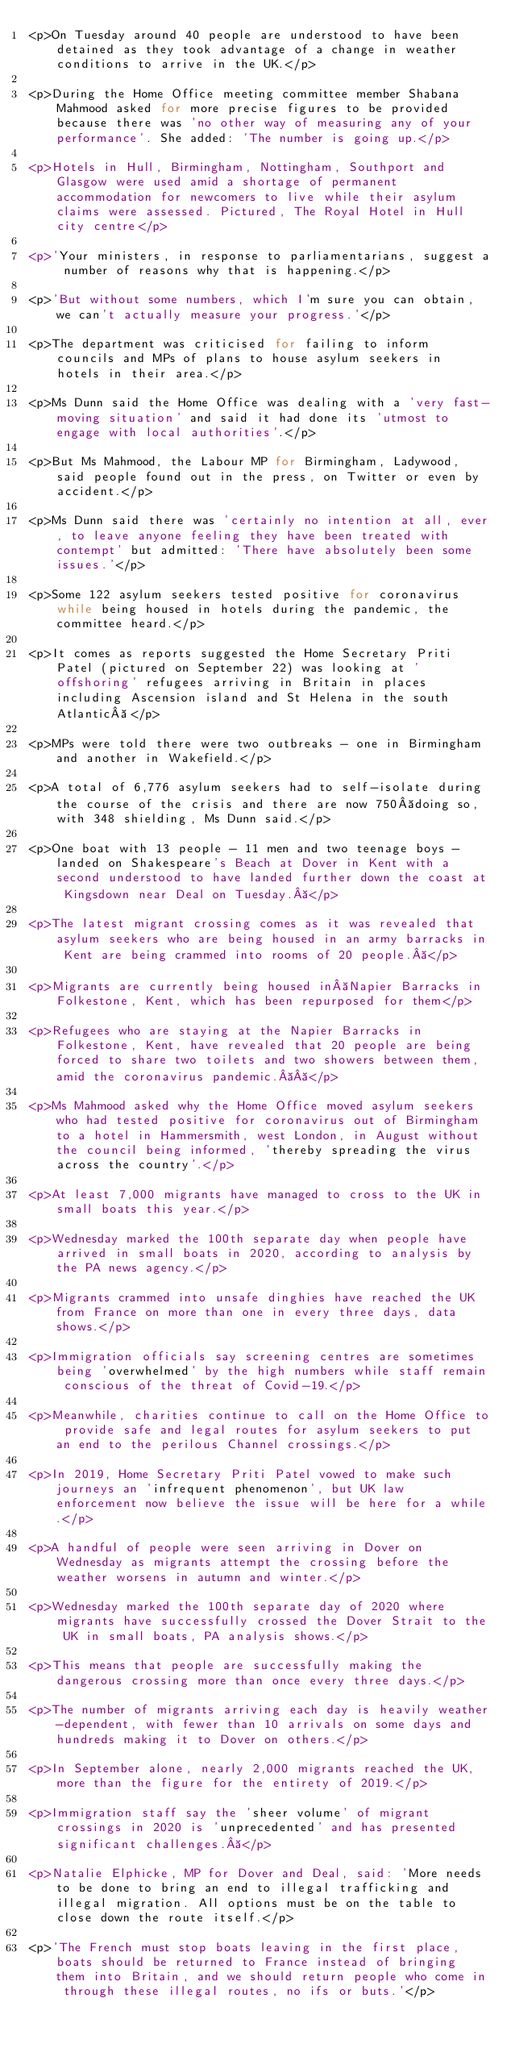Convert code to text. <code><loc_0><loc_0><loc_500><loc_500><_PHP_><p>On Tuesday around 40 people are understood to have been detained as they took advantage of a change in weather conditions to arrive in the UK.</p>

<p>During the Home Office meeting committee member Shabana Mahmood asked for more precise figures to be provided because there was 'no other way of measuring any of your performance'. She added: 'The number is going up.</p>

<p>Hotels in Hull, Birmingham, Nottingham, Southport and Glasgow were used amid a shortage of permanent accommodation for newcomers to live while their asylum claims were assessed. Pictured, The Royal Hotel in Hull city centre</p>

<p>'Your ministers, in response to parliamentarians, suggest a number of reasons why that is happening.</p>

<p>'But without some numbers, which I'm sure you can obtain, we can't actually measure your progress.'</p>

<p>The department was criticised for failing to inform councils and MPs of plans to house asylum seekers in hotels in their area.</p>

<p>Ms Dunn said the Home Office was dealing with a 'very fast-moving situation' and said it had done its 'utmost to engage with local authorities'.</p>

<p>But Ms Mahmood, the Labour MP for Birmingham, Ladywood, said people found out in the press, on Twitter or even by accident.</p>

<p>Ms Dunn said there was 'certainly no intention at all, ever, to leave anyone feeling they have been treated with contempt' but admitted: 'There have absolutely been some issues.'</p>

<p>Some 122 asylum seekers tested positive for coronavirus while being housed in hotels during the pandemic, the committee heard.</p>

<p>It comes as reports suggested the Home Secretary Priti Patel (pictured on September 22) was looking at 'offshoring' refugees arriving in Britain in places including Ascension island and St Helena in the south Atlantic </p>

<p>MPs were told there were two outbreaks - one in Birmingham and another in Wakefield.</p>

<p>A total of 6,776 asylum seekers had to self-isolate during the course of the crisis and there are now 750 doing so, with 348 shielding, Ms Dunn said.</p>

<p>One boat with 13 people - 11 men and two teenage boys - landed on Shakespeare's Beach at Dover in Kent with a second understood to have landed further down the coast at Kingsdown near Deal on Tuesday. </p>

<p>The latest migrant crossing comes as it was revealed that asylum seekers who are being housed in an army barracks in Kent are being crammed into rooms of 20 people. </p>

<p>Migrants are currently being housed in Napier Barracks in Folkestone, Kent, which has been repurposed for them</p>

<p>Refugees who are staying at the Napier Barracks in Folkestone, Kent, have revealed that 20 people are being forced to share two toilets and two showers between them, amid the coronavirus pandemic.  </p>

<p>Ms Mahmood asked why the Home Office moved asylum seekers who had tested positive for coronavirus out of Birmingham to a hotel in Hammersmith, west London, in August without the council being informed, 'thereby spreading the virus across the country'.</p>

<p>At least 7,000 migrants have managed to cross to the UK in small boats this year.</p>

<p>Wednesday marked the 100th separate day when people have arrived in small boats in 2020, according to analysis by the PA news agency.</p>

<p>Migrants crammed into unsafe dinghies have reached the UK from France on more than one in every three days, data shows.</p>

<p>Immigration officials say screening centres are sometimes being 'overwhelmed' by the high numbers while staff remain conscious of the threat of Covid-19.</p>

<p>Meanwhile, charities continue to call on the Home Office to provide safe and legal routes for asylum seekers to put an end to the perilous Channel crossings.</p>

<p>In 2019, Home Secretary Priti Patel vowed to make such journeys an 'infrequent phenomenon', but UK law enforcement now believe the issue will be here for a while.</p>

<p>A handful of people were seen arriving in Dover on Wednesday as migrants attempt the crossing before the weather worsens in autumn and winter.</p>

<p>Wednesday marked the 100th separate day of 2020 where migrants have successfully crossed the Dover Strait to the UK in small boats, PA analysis shows.</p>

<p>This means that people are successfully making the dangerous crossing more than once every three days.</p>

<p>The number of migrants arriving each day is heavily weather-dependent, with fewer than 10 arrivals on some days and hundreds making it to Dover on others.</p>

<p>In September alone, nearly 2,000 migrants reached the UK, more than the figure for the entirety of 2019.</p>

<p>Immigration staff say the 'sheer volume' of migrant crossings in 2020 is 'unprecedented' and has presented significant challenges. </p>

<p>Natalie Elphicke, MP for Dover and Deal, said: 'More needs to be done to bring an end to illegal trafficking and illegal migration. All options must be on the table to close down the route itself.</p>

<p>'The French must stop boats leaving in the first place, boats should be returned to France instead of bringing them into Britain, and we should return people who come in through these illegal routes, no ifs or buts.'</p>
</code> 